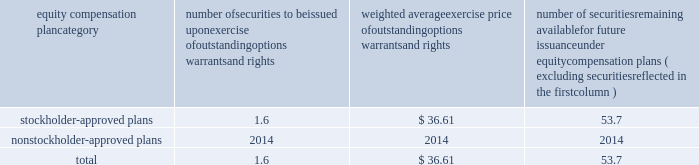Bhge 2017 form 10-k | 103 part iii item 10 .
Directors , executive officers and corporate governance information regarding our code of conduct , the spirit and the letter , and code of ethical conduct certificates for our principal executive officer , principal financial officer and principal accounting officer are described in item 1 .
Business of this annual report .
Information concerning our directors is set forth in the sections entitled "proposal no .
1 , election of directors - board nominees for directors" and "corporate governance - committees of the board" in our definitive proxy statement for the 2018 annual meeting of stockholders to be filed with the sec pursuant to the exchange act within 120 days of the end of our fiscal year on december 31 , 2017 ( "proxy statement" ) , which sections are incorporated herein by reference .
For information regarding our executive officers , see "item 1 .
Business - executive officers of baker hughes" in this annual report on form 10-k .
Additional information regarding compliance by directors and executive officers with section 16 ( a ) of the exchange act is set forth under the section entitled "section 16 ( a ) beneficial ownership reporting compliance" in our proxy statement , which section is incorporated herein by reference .
Item 11 .
Executive compensation information for this item is set forth in the following sections of our proxy statement , which sections are incorporated herein by reference : "compensation discussion and analysis" "director compensation" "compensation committee interlocks and insider participation" and "compensation committee report." item 12 .
Security ownership of certain beneficial owners and management and related stockholder matters information concerning security ownership of certain beneficial owners and our management is set forth in the sections entitled "stock ownership of certain beneficial owners" and 201cstock ownership of section 16 ( a ) director and executive officers 201d ) in our proxy statement , which sections are incorporated herein by reference .
We permit our employees , officers and directors to enter into written trading plans complying with rule 10b5-1 under the exchange act .
Rule 10b5-1 provides criteria under which such an individual may establish a prearranged plan to buy or sell a specified number of shares of a company's stock over a set period of time .
Any such plan must be entered into in good faith at a time when the individual is not in possession of material , nonpublic information .
If an individual establishes a plan satisfying the requirements of rule 10b5-1 , such individual's subsequent receipt of material , nonpublic information will not prevent transactions under the plan from being executed .
Certain of our officers have advised us that they have and may enter into stock sales plans for the sale of shares of our class a common stock which are intended to comply with the requirements of rule 10b5-1 of the exchange act .
In addition , the company has and may in the future enter into repurchases of our class a common stock under a plan that complies with rule 10b5-1 or rule 10b-18 of the exchange act .
Equity compensation plan information the information in the table is presented as of december 31 , 2017 with respect to shares of our class a common stock that may be issued under our lti plan which has been approved by our stockholders ( in millions , except per share prices ) .
Equity compensation plan category number of securities to be issued upon exercise of outstanding options , warrants and rights weighted average exercise price of outstanding options , warrants and rights number of securities remaining available for future issuance under equity compensation plans ( excluding securities reflected in the first column ) .

What is the total number of securities approved by stockholders? 
Computations: (1.6 + 53.7)
Answer: 55.3. 